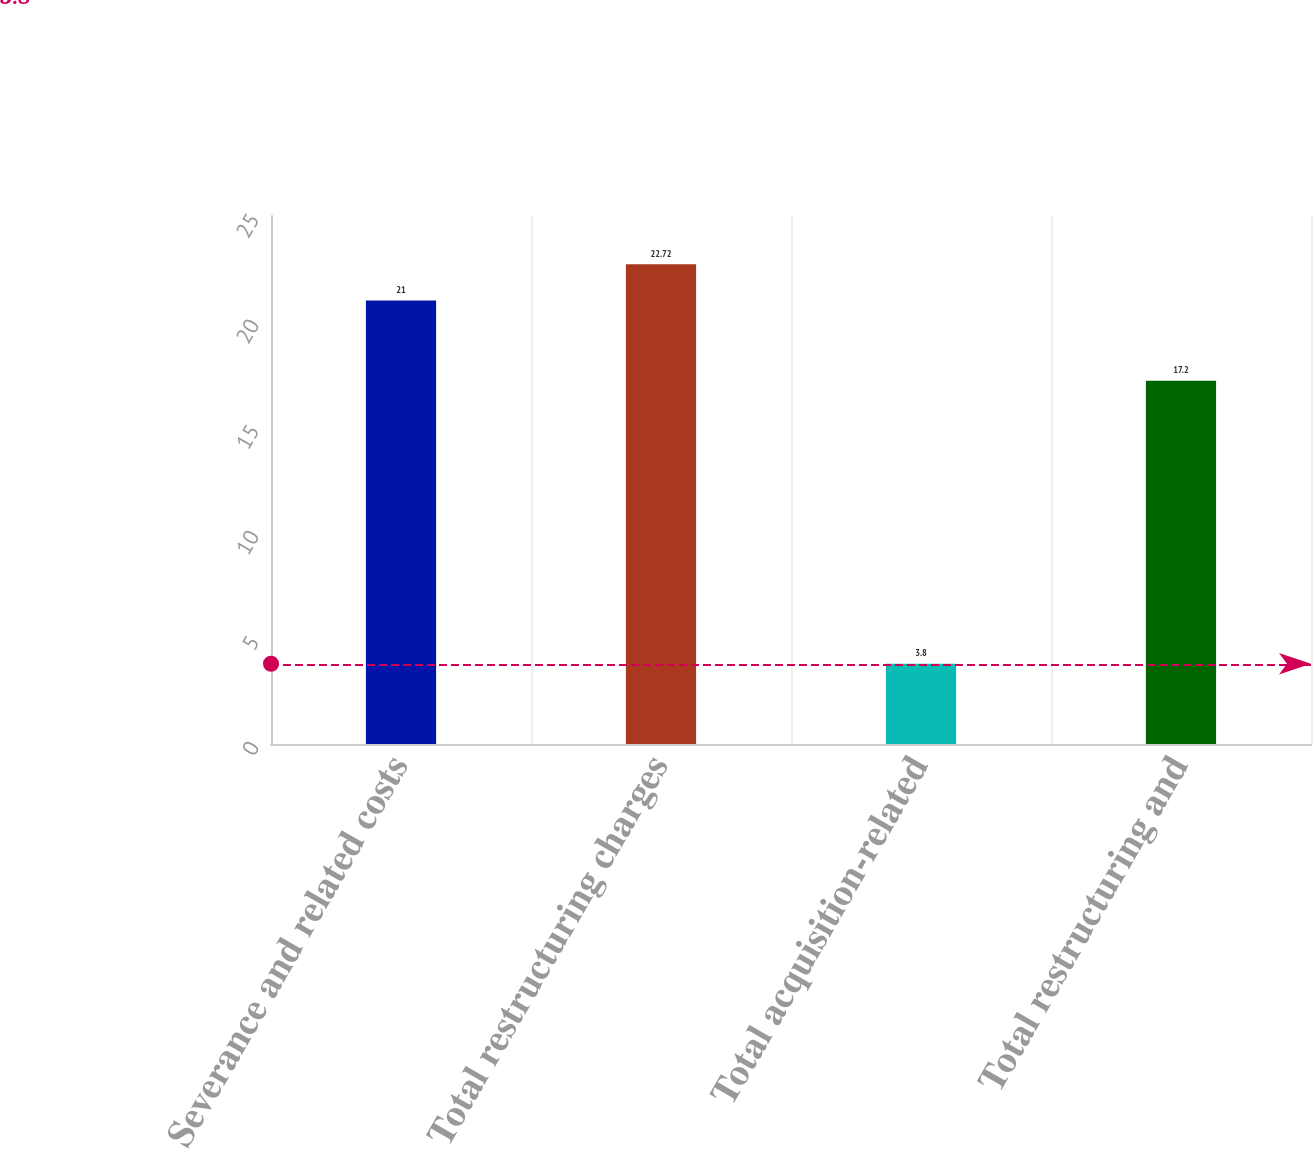<chart> <loc_0><loc_0><loc_500><loc_500><bar_chart><fcel>Severance and related costs<fcel>Total restructuring charges<fcel>Total acquisition-related<fcel>Total restructuring and<nl><fcel>21<fcel>22.72<fcel>3.8<fcel>17.2<nl></chart> 